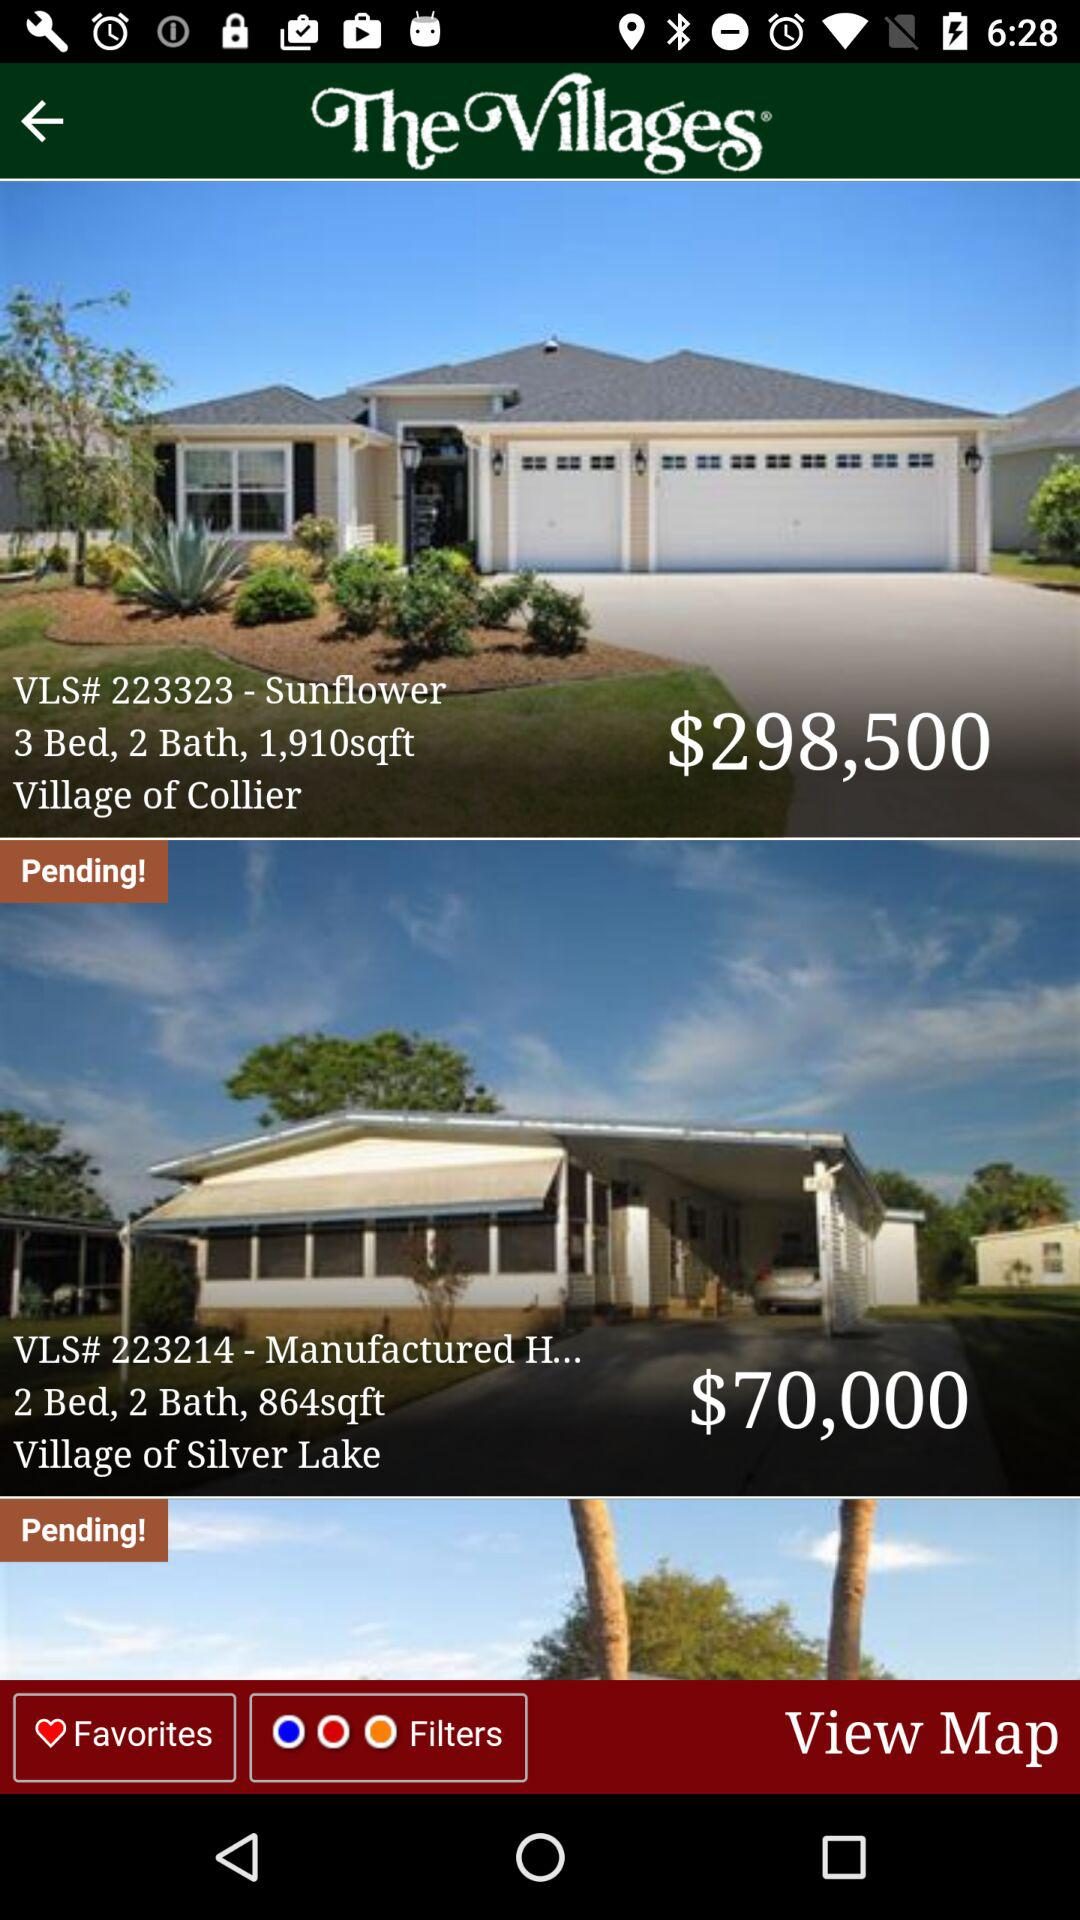What is the price of the Village of Silver Lake? The price of the Village of Silver Lake is $70,000. 